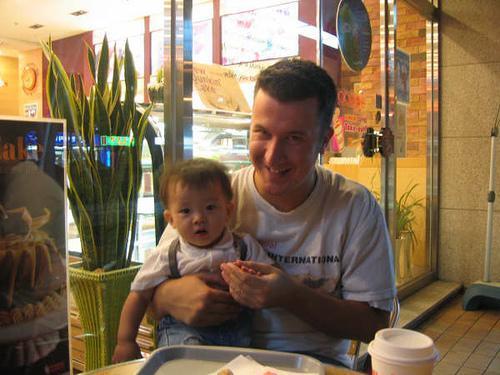How many hands are contacting with another person's skin or clothing?
Give a very brief answer. 3. 